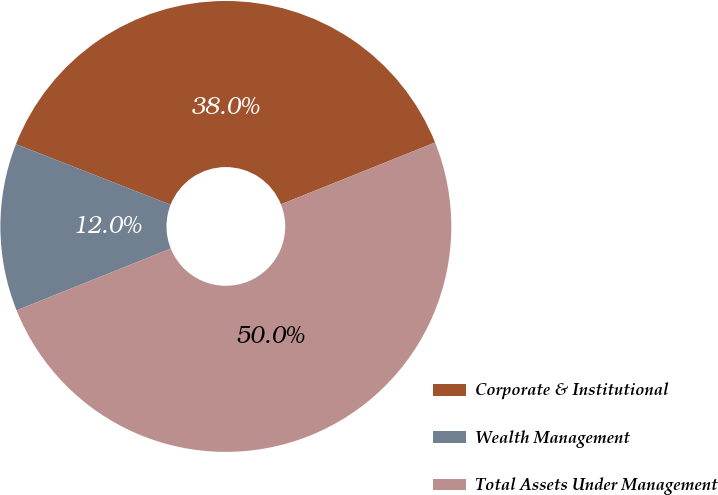Convert chart. <chart><loc_0><loc_0><loc_500><loc_500><pie_chart><fcel>Corporate & Institutional<fcel>Wealth Management<fcel>Total Assets Under Management<nl><fcel>37.98%<fcel>12.02%<fcel>50.0%<nl></chart> 